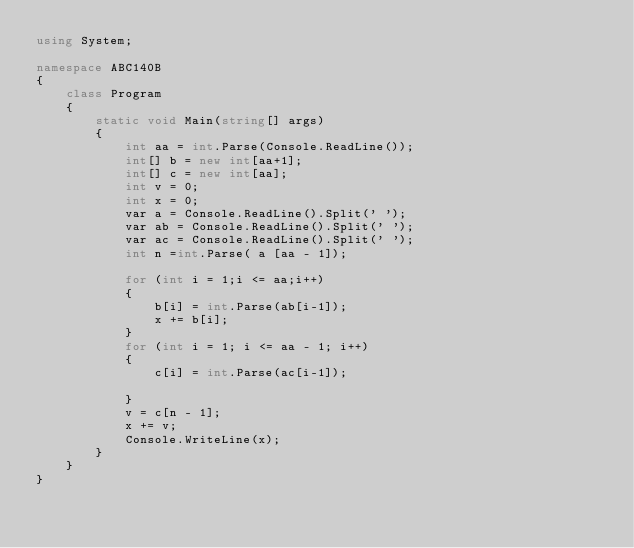<code> <loc_0><loc_0><loc_500><loc_500><_C#_>using System;

namespace ABC140B
{
    class Program
    {
        static void Main(string[] args)
        {
            int aa = int.Parse(Console.ReadLine());
            int[] b = new int[aa+1];
            int[] c = new int[aa];
            int v = 0;
            int x = 0;
            var a = Console.ReadLine().Split(' ');
            var ab = Console.ReadLine().Split(' ');
            var ac = Console.ReadLine().Split(' ');
            int n =int.Parse( a [aa - 1]);

            for (int i = 1;i <= aa;i++)
            {
                b[i] = int.Parse(ab[i-1]);
                x += b[i];
            }
            for (int i = 1; i <= aa - 1; i++)
            {
                c[i] = int.Parse(ac[i-1]);
               
            }
            v = c[n - 1];
            x += v;
            Console.WriteLine(x);
        }
    }
}
</code> 